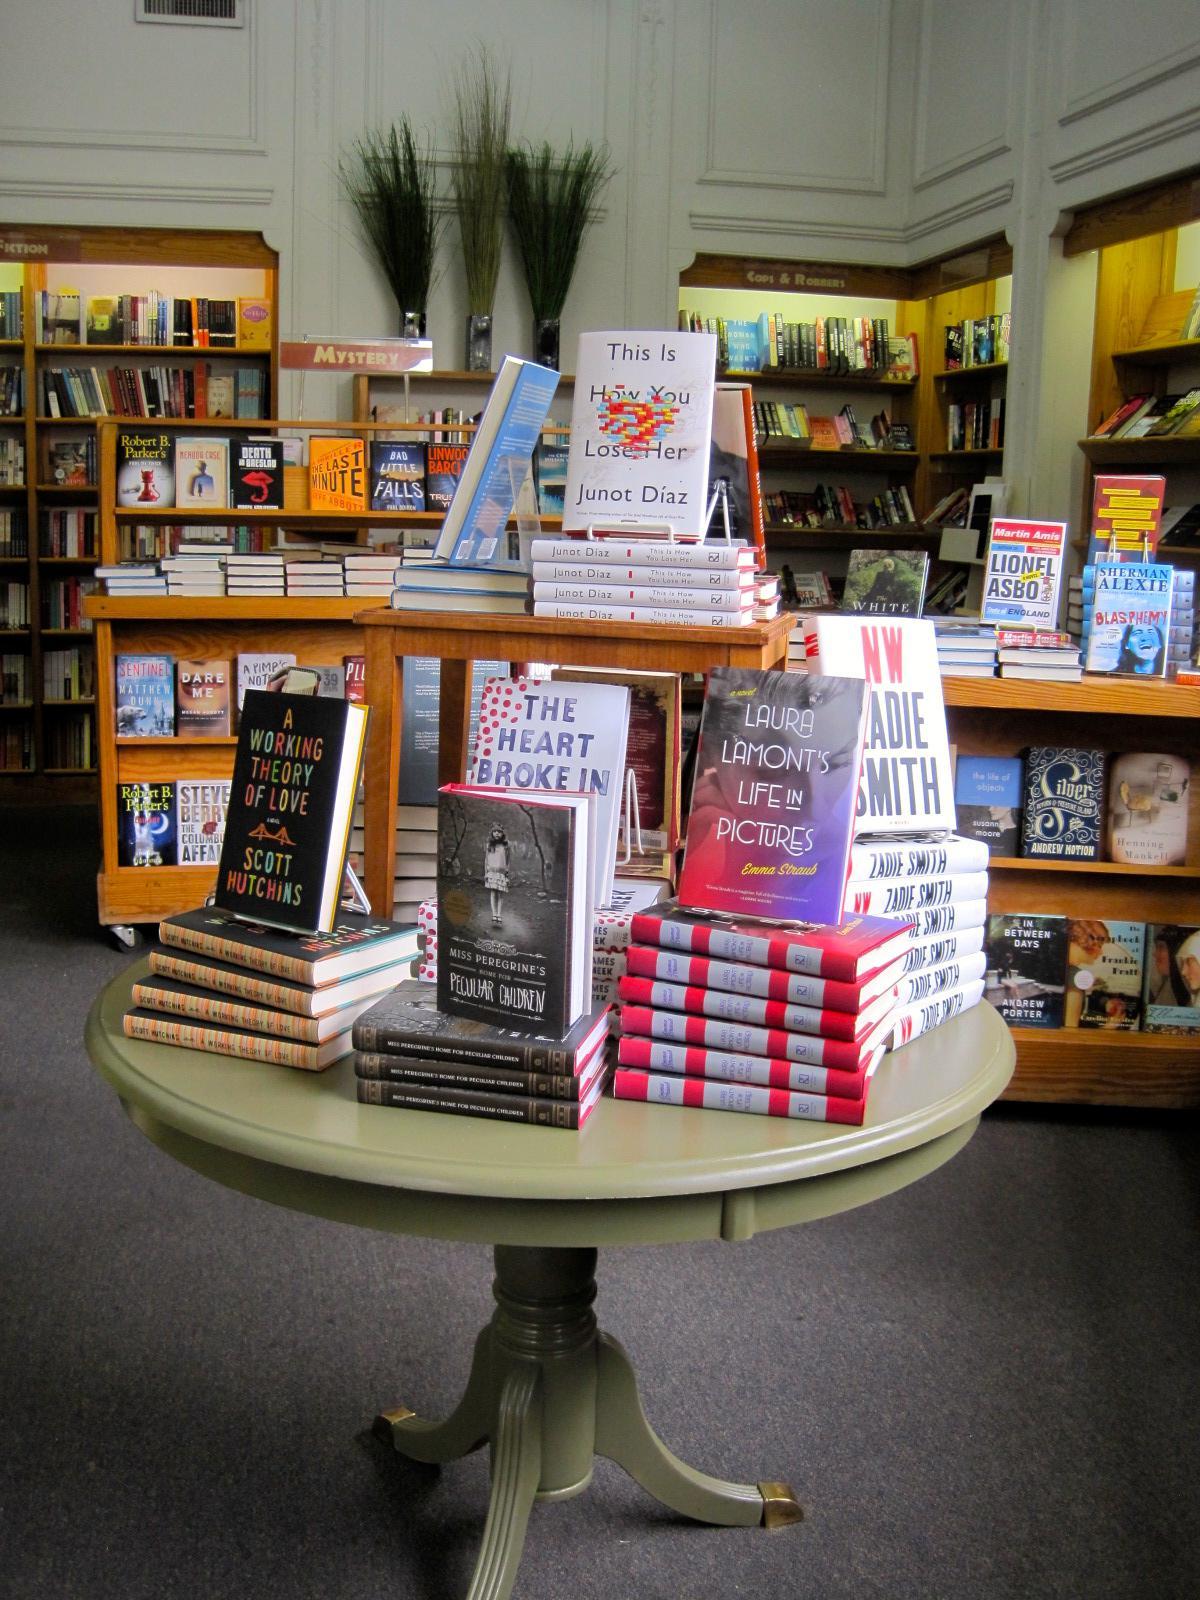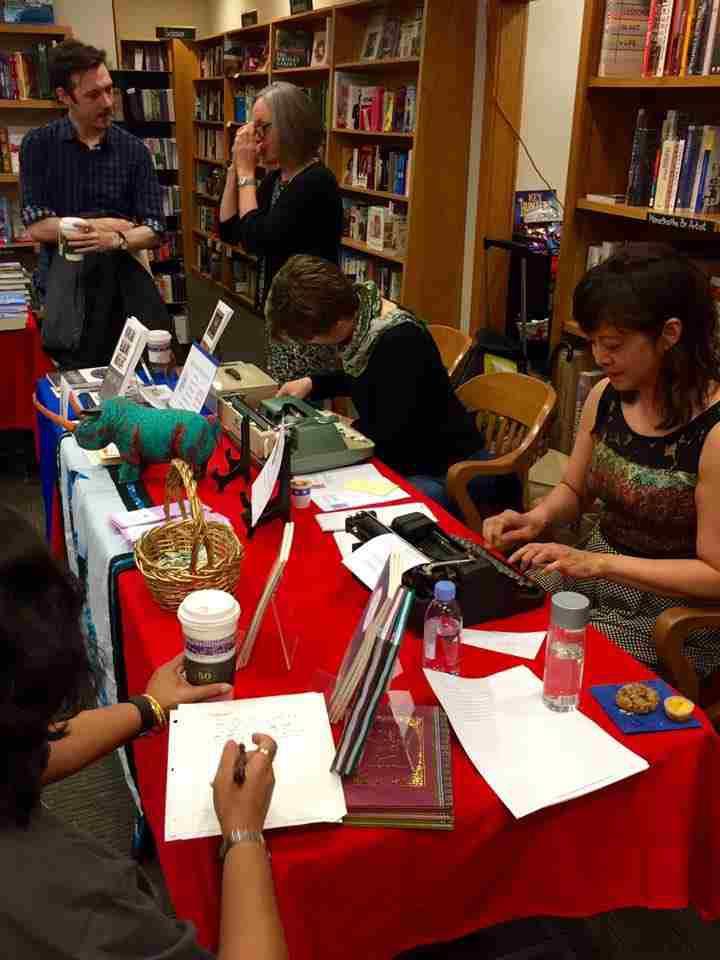The first image is the image on the left, the second image is the image on the right. For the images displayed, is the sentence "In at least one image there is an empty bookstore with at least 1 plant." factually correct? Answer yes or no. Yes. The first image is the image on the left, the second image is the image on the right. Evaluate the accuracy of this statement regarding the images: "The right image includes people sitting on opposite sides of a table with bookshelves in the background.". Is it true? Answer yes or no. Yes. 